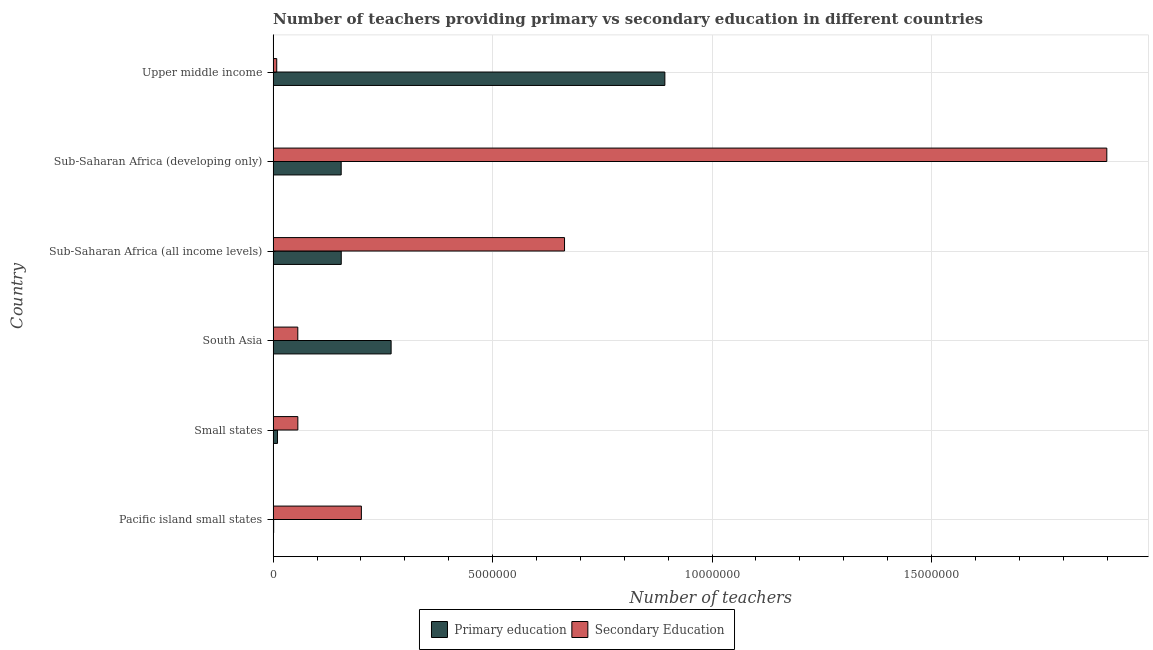How many different coloured bars are there?
Your response must be concise. 2. How many groups of bars are there?
Ensure brevity in your answer.  6. What is the label of the 3rd group of bars from the top?
Ensure brevity in your answer.  Sub-Saharan Africa (all income levels). What is the number of primary teachers in Pacific island small states?
Your answer should be compact. 1.21e+04. Across all countries, what is the maximum number of secondary teachers?
Your answer should be very brief. 1.90e+07. Across all countries, what is the minimum number of secondary teachers?
Provide a succinct answer. 8.22e+04. In which country was the number of primary teachers maximum?
Your answer should be very brief. Upper middle income. In which country was the number of primary teachers minimum?
Keep it short and to the point. Pacific island small states. What is the total number of secondary teachers in the graph?
Ensure brevity in your answer.  2.89e+07. What is the difference between the number of secondary teachers in Small states and that in Sub-Saharan Africa (developing only)?
Make the answer very short. -1.84e+07. What is the difference between the number of secondary teachers in South Asia and the number of primary teachers in Small states?
Give a very brief answer. 4.62e+05. What is the average number of primary teachers per country?
Your answer should be compact. 2.47e+06. What is the difference between the number of primary teachers and number of secondary teachers in Upper middle income?
Give a very brief answer. 8.84e+06. In how many countries, is the number of secondary teachers greater than 18000000 ?
Your response must be concise. 1. What is the ratio of the number of primary teachers in Sub-Saharan Africa (all income levels) to that in Sub-Saharan Africa (developing only)?
Provide a short and direct response. 1. Is the difference between the number of secondary teachers in South Asia and Sub-Saharan Africa (developing only) greater than the difference between the number of primary teachers in South Asia and Sub-Saharan Africa (developing only)?
Provide a succinct answer. No. What is the difference between the highest and the second highest number of primary teachers?
Ensure brevity in your answer.  6.24e+06. What is the difference between the highest and the lowest number of secondary teachers?
Provide a succinct answer. 1.89e+07. In how many countries, is the number of secondary teachers greater than the average number of secondary teachers taken over all countries?
Your response must be concise. 2. What does the 1st bar from the bottom in South Asia represents?
Make the answer very short. Primary education. Are all the bars in the graph horizontal?
Provide a short and direct response. Yes. What is the difference between two consecutive major ticks on the X-axis?
Keep it short and to the point. 5.00e+06. How many legend labels are there?
Your response must be concise. 2. What is the title of the graph?
Give a very brief answer. Number of teachers providing primary vs secondary education in different countries. What is the label or title of the X-axis?
Your answer should be very brief. Number of teachers. What is the label or title of the Y-axis?
Your answer should be compact. Country. What is the Number of teachers of Primary education in Pacific island small states?
Offer a very short reply. 1.21e+04. What is the Number of teachers in Secondary Education in Pacific island small states?
Provide a succinct answer. 2.01e+06. What is the Number of teachers of Primary education in Small states?
Provide a short and direct response. 1.00e+05. What is the Number of teachers of Secondary Education in Small states?
Offer a very short reply. 5.63e+05. What is the Number of teachers in Primary education in South Asia?
Your response must be concise. 2.69e+06. What is the Number of teachers of Secondary Education in South Asia?
Make the answer very short. 5.62e+05. What is the Number of teachers in Primary education in Sub-Saharan Africa (all income levels)?
Provide a short and direct response. 1.55e+06. What is the Number of teachers in Secondary Education in Sub-Saharan Africa (all income levels)?
Offer a terse response. 6.64e+06. What is the Number of teachers in Primary education in Sub-Saharan Africa (developing only)?
Your answer should be very brief. 1.55e+06. What is the Number of teachers in Secondary Education in Sub-Saharan Africa (developing only)?
Offer a very short reply. 1.90e+07. What is the Number of teachers in Primary education in Upper middle income?
Make the answer very short. 8.92e+06. What is the Number of teachers of Secondary Education in Upper middle income?
Your answer should be compact. 8.22e+04. Across all countries, what is the maximum Number of teachers of Primary education?
Your answer should be compact. 8.92e+06. Across all countries, what is the maximum Number of teachers in Secondary Education?
Ensure brevity in your answer.  1.90e+07. Across all countries, what is the minimum Number of teachers of Primary education?
Your answer should be compact. 1.21e+04. Across all countries, what is the minimum Number of teachers in Secondary Education?
Make the answer very short. 8.22e+04. What is the total Number of teachers in Primary education in the graph?
Provide a short and direct response. 1.48e+07. What is the total Number of teachers of Secondary Education in the graph?
Offer a terse response. 2.89e+07. What is the difference between the Number of teachers in Primary education in Pacific island small states and that in Small states?
Make the answer very short. -8.81e+04. What is the difference between the Number of teachers of Secondary Education in Pacific island small states and that in Small states?
Keep it short and to the point. 1.45e+06. What is the difference between the Number of teachers in Primary education in Pacific island small states and that in South Asia?
Provide a short and direct response. -2.68e+06. What is the difference between the Number of teachers in Secondary Education in Pacific island small states and that in South Asia?
Provide a succinct answer. 1.45e+06. What is the difference between the Number of teachers of Primary education in Pacific island small states and that in Sub-Saharan Africa (all income levels)?
Your answer should be compact. -1.54e+06. What is the difference between the Number of teachers of Secondary Education in Pacific island small states and that in Sub-Saharan Africa (all income levels)?
Provide a succinct answer. -4.63e+06. What is the difference between the Number of teachers in Primary education in Pacific island small states and that in Sub-Saharan Africa (developing only)?
Give a very brief answer. -1.54e+06. What is the difference between the Number of teachers in Secondary Education in Pacific island small states and that in Sub-Saharan Africa (developing only)?
Keep it short and to the point. -1.70e+07. What is the difference between the Number of teachers of Primary education in Pacific island small states and that in Upper middle income?
Ensure brevity in your answer.  -8.91e+06. What is the difference between the Number of teachers in Secondary Education in Pacific island small states and that in Upper middle income?
Provide a succinct answer. 1.93e+06. What is the difference between the Number of teachers of Primary education in Small states and that in South Asia?
Offer a very short reply. -2.59e+06. What is the difference between the Number of teachers of Secondary Education in Small states and that in South Asia?
Offer a terse response. 988.69. What is the difference between the Number of teachers of Primary education in Small states and that in Sub-Saharan Africa (all income levels)?
Your response must be concise. -1.45e+06. What is the difference between the Number of teachers in Secondary Education in Small states and that in Sub-Saharan Africa (all income levels)?
Provide a succinct answer. -6.08e+06. What is the difference between the Number of teachers in Primary education in Small states and that in Sub-Saharan Africa (developing only)?
Your answer should be compact. -1.45e+06. What is the difference between the Number of teachers in Secondary Education in Small states and that in Sub-Saharan Africa (developing only)?
Provide a succinct answer. -1.84e+07. What is the difference between the Number of teachers of Primary education in Small states and that in Upper middle income?
Provide a succinct answer. -8.82e+06. What is the difference between the Number of teachers of Secondary Education in Small states and that in Upper middle income?
Your answer should be very brief. 4.81e+05. What is the difference between the Number of teachers of Primary education in South Asia and that in Sub-Saharan Africa (all income levels)?
Ensure brevity in your answer.  1.14e+06. What is the difference between the Number of teachers of Secondary Education in South Asia and that in Sub-Saharan Africa (all income levels)?
Provide a short and direct response. -6.08e+06. What is the difference between the Number of teachers of Primary education in South Asia and that in Sub-Saharan Africa (developing only)?
Make the answer very short. 1.14e+06. What is the difference between the Number of teachers of Secondary Education in South Asia and that in Sub-Saharan Africa (developing only)?
Provide a succinct answer. -1.84e+07. What is the difference between the Number of teachers of Primary education in South Asia and that in Upper middle income?
Your response must be concise. -6.24e+06. What is the difference between the Number of teachers of Secondary Education in South Asia and that in Upper middle income?
Provide a short and direct response. 4.80e+05. What is the difference between the Number of teachers in Primary education in Sub-Saharan Africa (all income levels) and that in Sub-Saharan Africa (developing only)?
Offer a very short reply. 1348.62. What is the difference between the Number of teachers of Secondary Education in Sub-Saharan Africa (all income levels) and that in Sub-Saharan Africa (developing only)?
Give a very brief answer. -1.24e+07. What is the difference between the Number of teachers of Primary education in Sub-Saharan Africa (all income levels) and that in Upper middle income?
Offer a terse response. -7.37e+06. What is the difference between the Number of teachers of Secondary Education in Sub-Saharan Africa (all income levels) and that in Upper middle income?
Give a very brief answer. 6.56e+06. What is the difference between the Number of teachers of Primary education in Sub-Saharan Africa (developing only) and that in Upper middle income?
Offer a very short reply. -7.37e+06. What is the difference between the Number of teachers of Secondary Education in Sub-Saharan Africa (developing only) and that in Upper middle income?
Ensure brevity in your answer.  1.89e+07. What is the difference between the Number of teachers of Primary education in Pacific island small states and the Number of teachers of Secondary Education in Small states?
Make the answer very short. -5.51e+05. What is the difference between the Number of teachers in Primary education in Pacific island small states and the Number of teachers in Secondary Education in South Asia?
Your response must be concise. -5.50e+05. What is the difference between the Number of teachers of Primary education in Pacific island small states and the Number of teachers of Secondary Education in Sub-Saharan Africa (all income levels)?
Provide a succinct answer. -6.63e+06. What is the difference between the Number of teachers of Primary education in Pacific island small states and the Number of teachers of Secondary Education in Sub-Saharan Africa (developing only)?
Ensure brevity in your answer.  -1.90e+07. What is the difference between the Number of teachers of Primary education in Pacific island small states and the Number of teachers of Secondary Education in Upper middle income?
Provide a short and direct response. -7.01e+04. What is the difference between the Number of teachers in Primary education in Small states and the Number of teachers in Secondary Education in South Asia?
Keep it short and to the point. -4.62e+05. What is the difference between the Number of teachers in Primary education in Small states and the Number of teachers in Secondary Education in Sub-Saharan Africa (all income levels)?
Provide a succinct answer. -6.54e+06. What is the difference between the Number of teachers of Primary education in Small states and the Number of teachers of Secondary Education in Sub-Saharan Africa (developing only)?
Offer a terse response. -1.89e+07. What is the difference between the Number of teachers in Primary education in Small states and the Number of teachers in Secondary Education in Upper middle income?
Give a very brief answer. 1.80e+04. What is the difference between the Number of teachers in Primary education in South Asia and the Number of teachers in Secondary Education in Sub-Saharan Africa (all income levels)?
Provide a succinct answer. -3.95e+06. What is the difference between the Number of teachers of Primary education in South Asia and the Number of teachers of Secondary Education in Sub-Saharan Africa (developing only)?
Offer a terse response. -1.63e+07. What is the difference between the Number of teachers of Primary education in South Asia and the Number of teachers of Secondary Education in Upper middle income?
Keep it short and to the point. 2.61e+06. What is the difference between the Number of teachers of Primary education in Sub-Saharan Africa (all income levels) and the Number of teachers of Secondary Education in Sub-Saharan Africa (developing only)?
Your answer should be very brief. -1.74e+07. What is the difference between the Number of teachers in Primary education in Sub-Saharan Africa (all income levels) and the Number of teachers in Secondary Education in Upper middle income?
Keep it short and to the point. 1.47e+06. What is the difference between the Number of teachers in Primary education in Sub-Saharan Africa (developing only) and the Number of teachers in Secondary Education in Upper middle income?
Provide a short and direct response. 1.47e+06. What is the average Number of teachers of Primary education per country?
Your answer should be very brief. 2.47e+06. What is the average Number of teachers of Secondary Education per country?
Provide a short and direct response. 4.81e+06. What is the difference between the Number of teachers in Primary education and Number of teachers in Secondary Education in Pacific island small states?
Provide a succinct answer. -2.00e+06. What is the difference between the Number of teachers in Primary education and Number of teachers in Secondary Education in Small states?
Provide a succinct answer. -4.63e+05. What is the difference between the Number of teachers of Primary education and Number of teachers of Secondary Education in South Asia?
Provide a short and direct response. 2.13e+06. What is the difference between the Number of teachers in Primary education and Number of teachers in Secondary Education in Sub-Saharan Africa (all income levels)?
Keep it short and to the point. -5.09e+06. What is the difference between the Number of teachers of Primary education and Number of teachers of Secondary Education in Sub-Saharan Africa (developing only)?
Your answer should be very brief. -1.74e+07. What is the difference between the Number of teachers of Primary education and Number of teachers of Secondary Education in Upper middle income?
Make the answer very short. 8.84e+06. What is the ratio of the Number of teachers of Primary education in Pacific island small states to that in Small states?
Ensure brevity in your answer.  0.12. What is the ratio of the Number of teachers of Secondary Education in Pacific island small states to that in Small states?
Offer a very short reply. 3.57. What is the ratio of the Number of teachers of Primary education in Pacific island small states to that in South Asia?
Offer a very short reply. 0. What is the ratio of the Number of teachers of Secondary Education in Pacific island small states to that in South Asia?
Give a very brief answer. 3.58. What is the ratio of the Number of teachers of Primary education in Pacific island small states to that in Sub-Saharan Africa (all income levels)?
Your response must be concise. 0.01. What is the ratio of the Number of teachers in Secondary Education in Pacific island small states to that in Sub-Saharan Africa (all income levels)?
Ensure brevity in your answer.  0.3. What is the ratio of the Number of teachers of Primary education in Pacific island small states to that in Sub-Saharan Africa (developing only)?
Keep it short and to the point. 0.01. What is the ratio of the Number of teachers in Secondary Education in Pacific island small states to that in Sub-Saharan Africa (developing only)?
Your answer should be compact. 0.11. What is the ratio of the Number of teachers in Primary education in Pacific island small states to that in Upper middle income?
Make the answer very short. 0. What is the ratio of the Number of teachers of Secondary Education in Pacific island small states to that in Upper middle income?
Ensure brevity in your answer.  24.45. What is the ratio of the Number of teachers of Primary education in Small states to that in South Asia?
Provide a short and direct response. 0.04. What is the ratio of the Number of teachers of Primary education in Small states to that in Sub-Saharan Africa (all income levels)?
Offer a terse response. 0.06. What is the ratio of the Number of teachers of Secondary Education in Small states to that in Sub-Saharan Africa (all income levels)?
Ensure brevity in your answer.  0.08. What is the ratio of the Number of teachers of Primary education in Small states to that in Sub-Saharan Africa (developing only)?
Your response must be concise. 0.06. What is the ratio of the Number of teachers of Secondary Education in Small states to that in Sub-Saharan Africa (developing only)?
Your answer should be very brief. 0.03. What is the ratio of the Number of teachers of Primary education in Small states to that in Upper middle income?
Your answer should be very brief. 0.01. What is the ratio of the Number of teachers of Secondary Education in Small states to that in Upper middle income?
Provide a succinct answer. 6.85. What is the ratio of the Number of teachers of Primary education in South Asia to that in Sub-Saharan Africa (all income levels)?
Offer a very short reply. 1.73. What is the ratio of the Number of teachers in Secondary Education in South Asia to that in Sub-Saharan Africa (all income levels)?
Keep it short and to the point. 0.08. What is the ratio of the Number of teachers of Primary education in South Asia to that in Sub-Saharan Africa (developing only)?
Your response must be concise. 1.73. What is the ratio of the Number of teachers in Secondary Education in South Asia to that in Sub-Saharan Africa (developing only)?
Ensure brevity in your answer.  0.03. What is the ratio of the Number of teachers in Primary education in South Asia to that in Upper middle income?
Make the answer very short. 0.3. What is the ratio of the Number of teachers in Secondary Education in South Asia to that in Upper middle income?
Make the answer very short. 6.84. What is the ratio of the Number of teachers in Secondary Education in Sub-Saharan Africa (all income levels) to that in Sub-Saharan Africa (developing only)?
Keep it short and to the point. 0.35. What is the ratio of the Number of teachers of Primary education in Sub-Saharan Africa (all income levels) to that in Upper middle income?
Your answer should be compact. 0.17. What is the ratio of the Number of teachers in Secondary Education in Sub-Saharan Africa (all income levels) to that in Upper middle income?
Keep it short and to the point. 80.75. What is the ratio of the Number of teachers in Primary education in Sub-Saharan Africa (developing only) to that in Upper middle income?
Keep it short and to the point. 0.17. What is the ratio of the Number of teachers of Secondary Education in Sub-Saharan Africa (developing only) to that in Upper middle income?
Ensure brevity in your answer.  231.02. What is the difference between the highest and the second highest Number of teachers in Primary education?
Offer a terse response. 6.24e+06. What is the difference between the highest and the second highest Number of teachers in Secondary Education?
Your answer should be compact. 1.24e+07. What is the difference between the highest and the lowest Number of teachers of Primary education?
Ensure brevity in your answer.  8.91e+06. What is the difference between the highest and the lowest Number of teachers of Secondary Education?
Make the answer very short. 1.89e+07. 